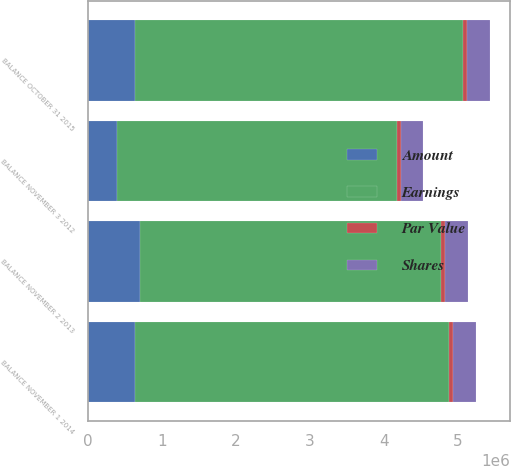<chart> <loc_0><loc_0><loc_500><loc_500><stacked_bar_chart><ecel><fcel>BALANCE NOVEMBER 3 2012<fcel>BALANCE NOVEMBER 2 2013<fcel>BALANCE NOVEMBER 1 2014<fcel>BALANCE OCTOBER 31 2015<nl><fcel>Shares<fcel>301389<fcel>311045<fcel>311205<fcel>312061<nl><fcel>Par Value<fcel>50233<fcel>51842<fcel>51869<fcel>52011<nl><fcel>Amount<fcel>390651<fcel>711879<fcel>643058<fcel>634484<nl><fcel>Earnings<fcel>3.78887e+06<fcel>4.0564e+06<fcel>4.2315e+06<fcel>4.43732e+06<nl></chart> 